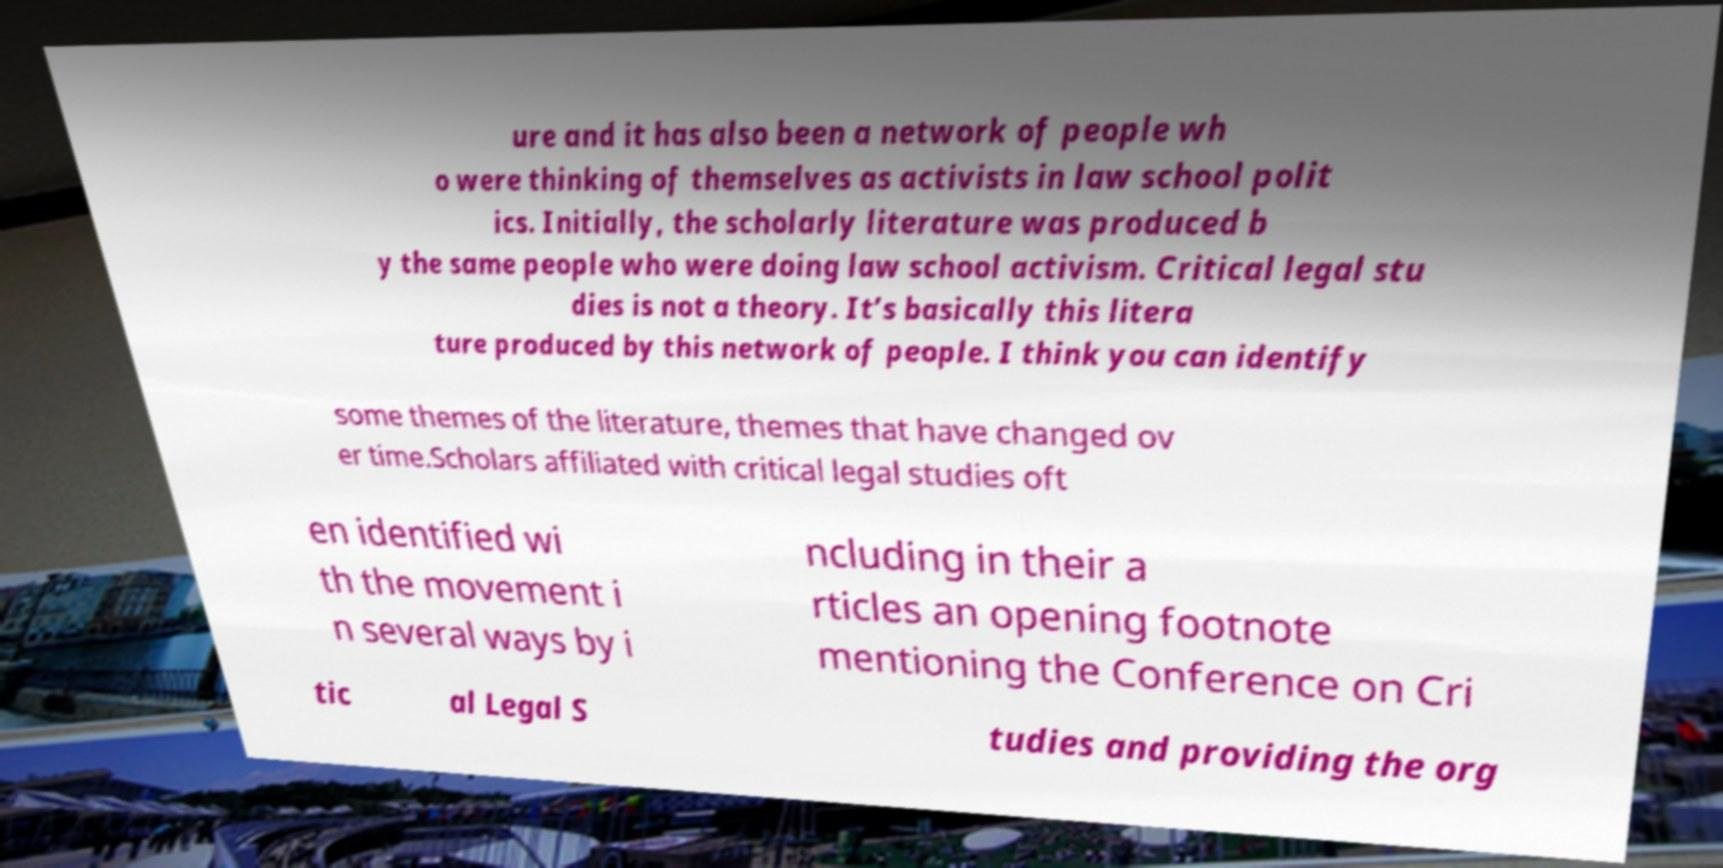Could you extract and type out the text from this image? ure and it has also been a network of people wh o were thinking of themselves as activists in law school polit ics. Initially, the scholarly literature was produced b y the same people who were doing law school activism. Critical legal stu dies is not a theory. It’s basically this litera ture produced by this network of people. I think you can identify some themes of the literature, themes that have changed ov er time.Scholars affiliated with critical legal studies oft en identified wi th the movement i n several ways by i ncluding in their a rticles an opening footnote mentioning the Conference on Cri tic al Legal S tudies and providing the org 